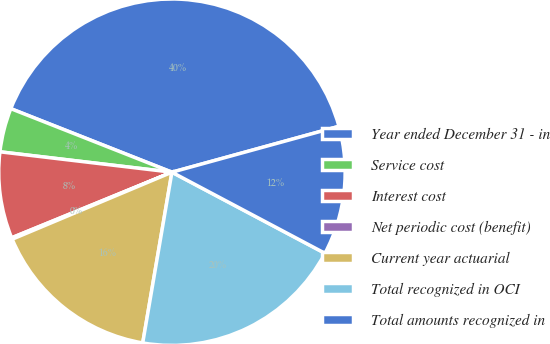Convert chart. <chart><loc_0><loc_0><loc_500><loc_500><pie_chart><fcel>Year ended December 31 - in<fcel>Service cost<fcel>Interest cost<fcel>Net periodic cost (benefit)<fcel>Current year actuarial<fcel>Total recognized in OCI<fcel>Total amounts recognized in<nl><fcel>39.75%<fcel>4.1%<fcel>8.06%<fcel>0.14%<fcel>15.98%<fcel>19.94%<fcel>12.02%<nl></chart> 